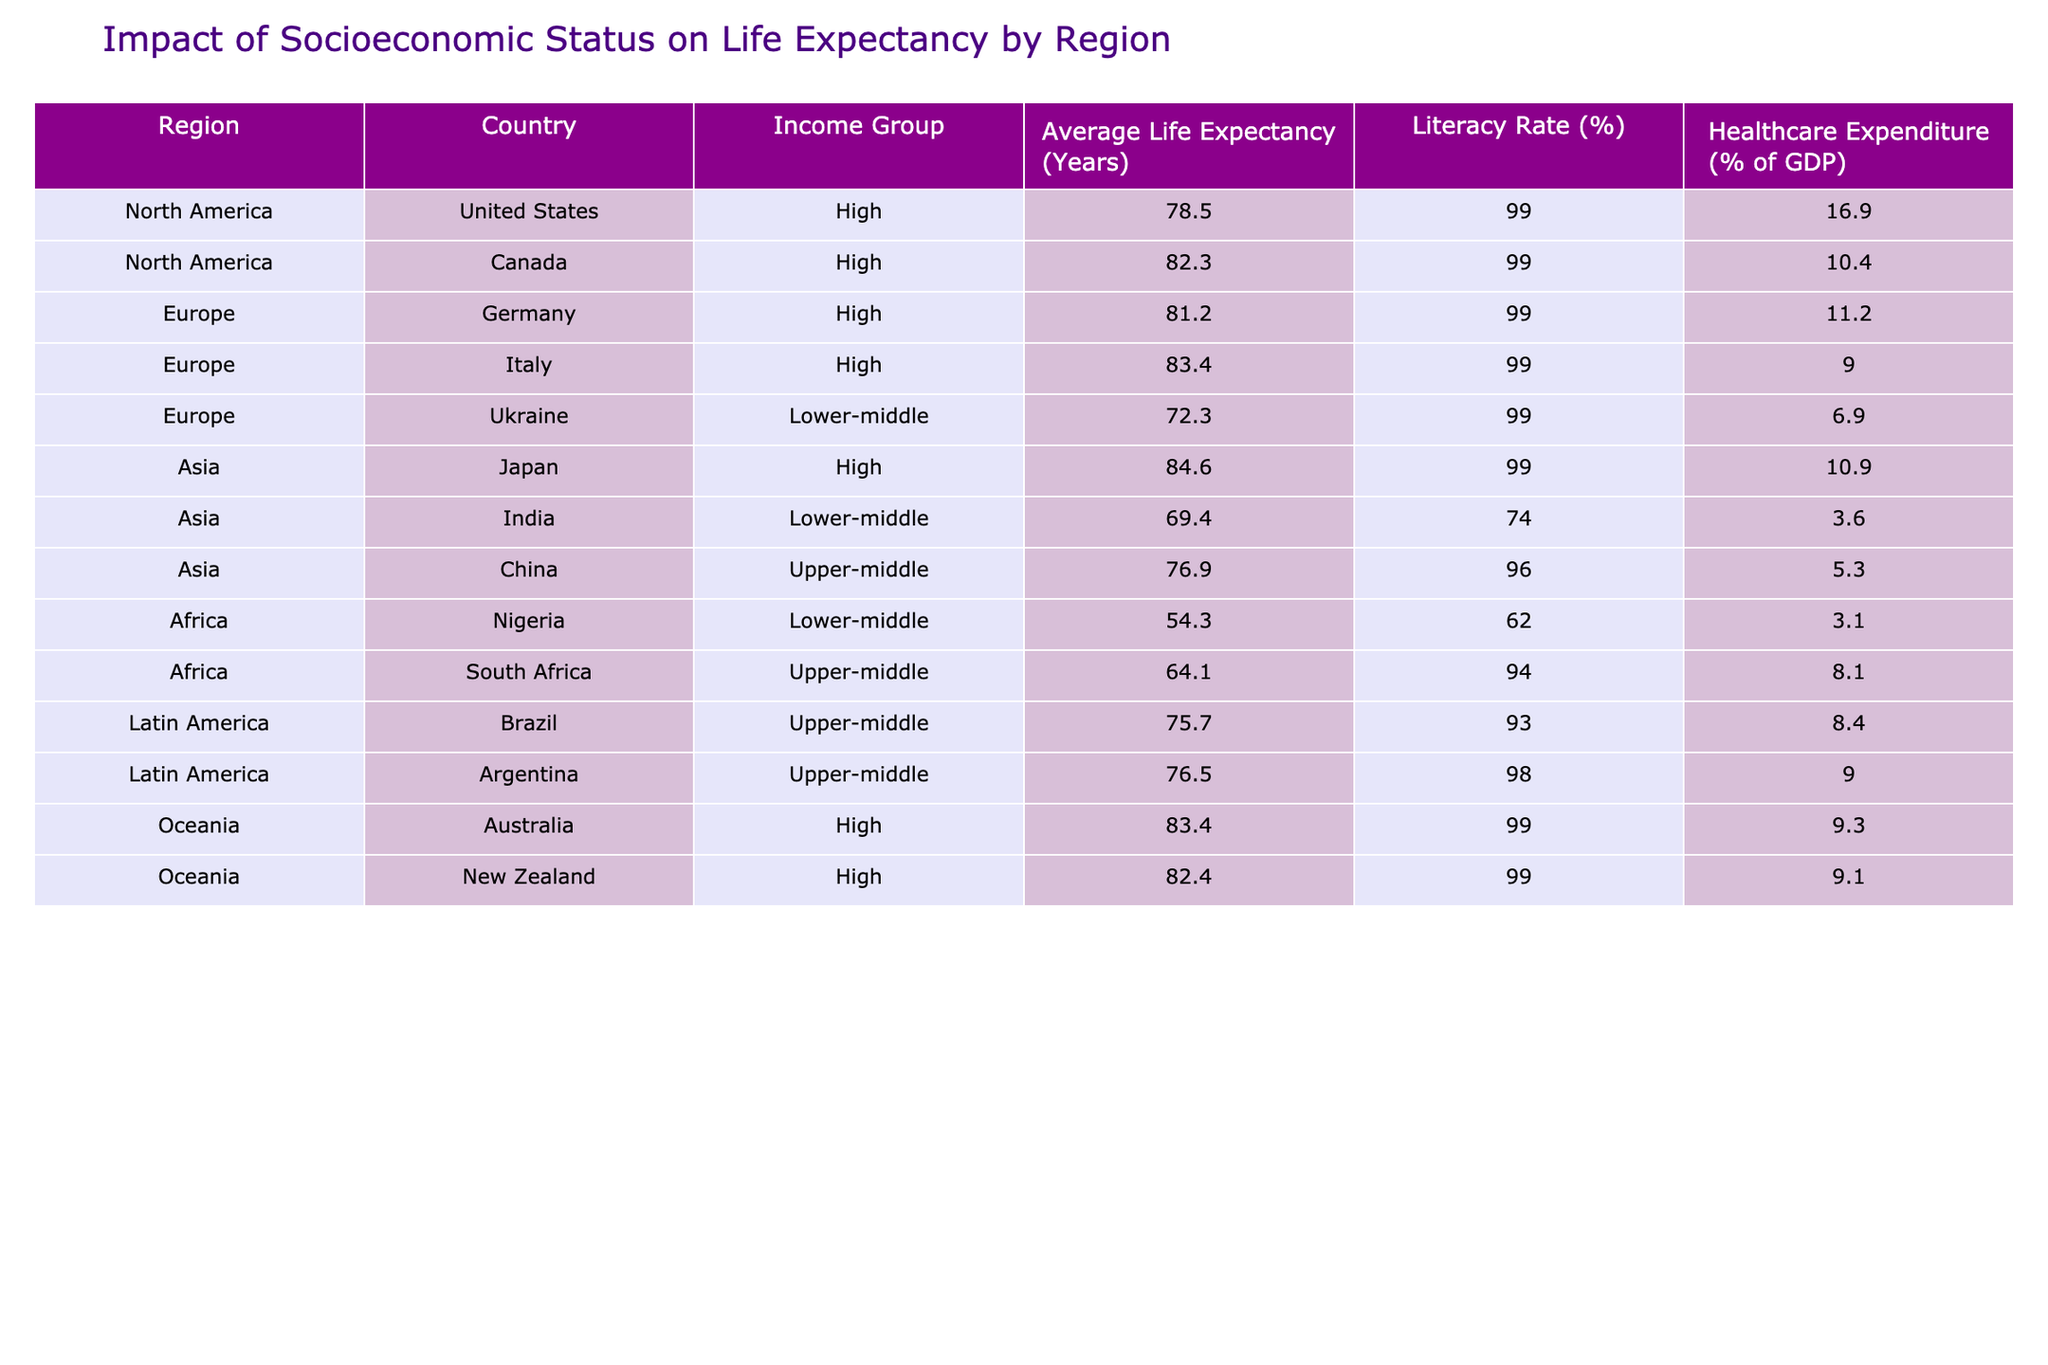What is the average life expectancy for high-income countries in Europe? The high-income countries in Europe listed are Germany and Italy. Their life expectancies are 81.2 years and 83.4 years, respectively. To find the average, add these two values together: 81.2 + 83.4 = 164.6. Then, divide by the number of countries, which is 2: 164.6 / 2 = 82.3 years.
Answer: 82.3 Which region has the lowest average life expectancy? The only country in Africa listed is Nigeria with a life expectancy of 54.3 years. Since this is lower than any other country in the table, it indicates that Africa has the lowest average life expectancy according to the data.
Answer: Africa Is the literacy rate in Japan higher than that in India? The literacy rate for Japan is listed as 99%, while for India it is 74%. Since 99% is greater than 74%, the statement is true.
Answer: Yes What is the difference in average life expectancy between the United States and Canada? The life expectancy in the United States is 78.5 years and in Canada, it is 82.3 years. To find the difference, subtract the life expectancy of the United States from that of Canada: 82.3 - 78.5 = 3.8 years.
Answer: 3.8 Are there any countries in the Upper-middle income group with a life expectancy above 75 years? The countries in the Upper-middle income group listed are China, South Africa, Brazil, and Argentina. Their life expectancies are 76.9, 64.1, 75.7, and 76.5 years, respectively. China, Brazil, and Argentina have life expectancies above 75 years, while South Africa does not. Therefore, the answer is yes.
Answer: Yes What is the average healthcare expenditure as a percentage of GDP for countries in the Lower-middle income group? The Lower-middle income countries are Ukraine and India with healthcare expenditure percentages of 6.9 and 3.6, respectively. To find the average, add these two values: 6.9 + 3.6 = 10.5. Then divide by the number of countries, which is 2: 10.5 / 2 = 5.25%.
Answer: 5.25 Which country has the highest healthcare expenditure as a percentage of GDP, and what is that value? Looking through the healthcare expenditure percentages of the countries listed, the United States has the highest at 16.9%. No other country in the data has a higher value than this.
Answer: United States, 16.9 What region has the highest average life expectancy of all listed countries? The countries in the table with the highest life expectancy is Japan with 84.6 years. Since no other country listed surpasses this figure, it shows that Asia has the highest average life expectancy in the region.
Answer: Asia 